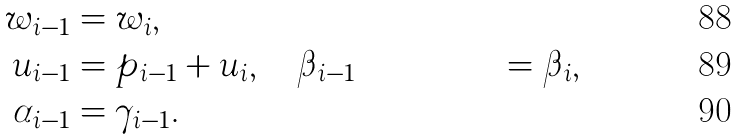Convert formula to latex. <formula><loc_0><loc_0><loc_500><loc_500>w _ { i - 1 } & = w _ { i } , \\ u _ { i - 1 } & = p _ { i - 1 } + u _ { i } , \quad \beta _ { i - 1 } & = \beta _ { i } , \\ \alpha _ { i - 1 } & = \gamma _ { i - 1 } .</formula> 